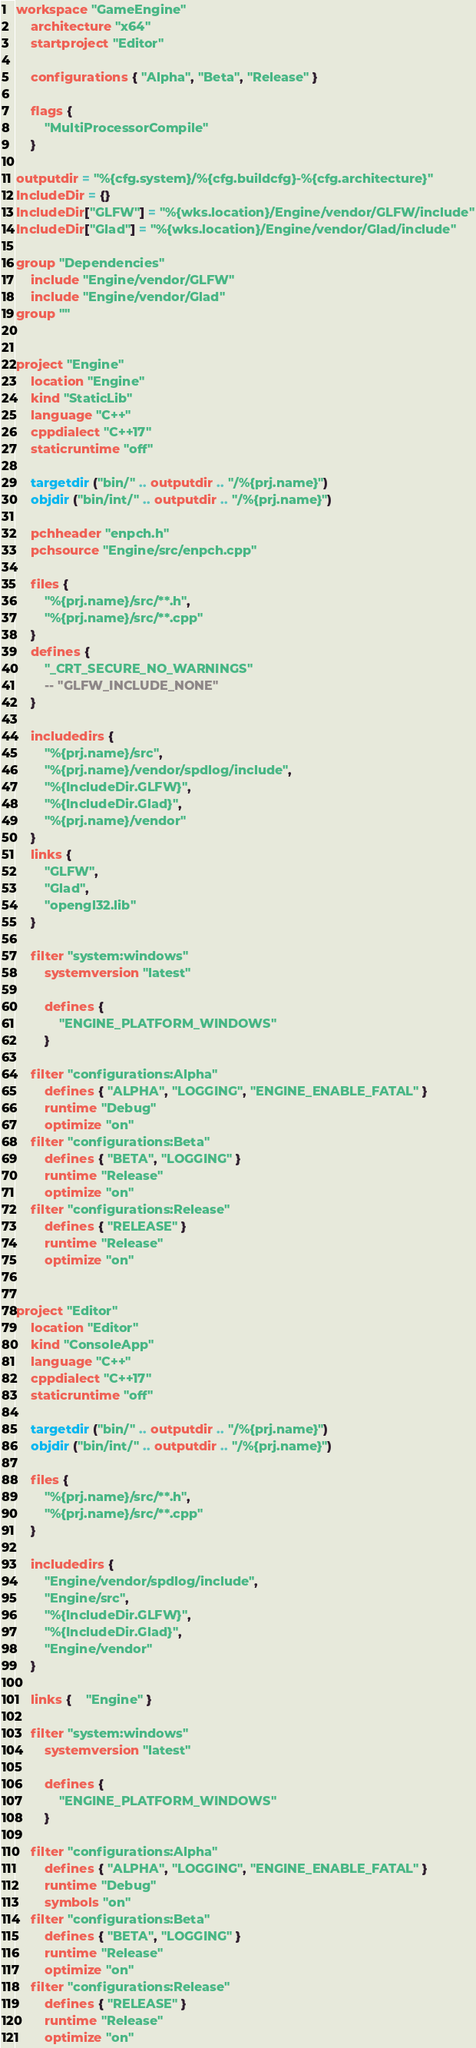<code> <loc_0><loc_0><loc_500><loc_500><_Lua_>workspace "GameEngine"
	architecture "x64"
	startproject "Editor"

	configurations { "Alpha", "Beta", "Release" }
	
	flags {
		"MultiProcessorCompile"
	}

outputdir = "%{cfg.system}/%{cfg.buildcfg}-%{cfg.architecture}"
IncludeDir = {}
IncludeDir["GLFW"] = "%{wks.location}/Engine/vendor/GLFW/include"
IncludeDir["Glad"] = "%{wks.location}/Engine/vendor/Glad/include"

group "Dependencies"
	include "Engine/vendor/GLFW"
	include "Engine/vendor/Glad"
group ""


project "Engine"
	location "Engine"
	kind "StaticLib"
	language "C++"
	cppdialect "C++17"
	staticruntime "off"
	
	targetdir ("bin/" .. outputdir .. "/%{prj.name}")
	objdir ("bin/int/" .. outputdir .. "/%{prj.name}")

	pchheader "enpch.h"
	pchsource "Engine/src/enpch.cpp"

	files {
		"%{prj.name}/src/**.h",
		"%{prj.name}/src/**.cpp"
	}
	defines {
		"_CRT_SECURE_NO_WARNINGS"
		-- "GLFW_INCLUDE_NONE"
	}

	includedirs {
		"%{prj.name}/src",
		"%{prj.name}/vendor/spdlog/include",
		"%{IncludeDir.GLFW}",
		"%{IncludeDir.Glad}",
		"%{prj.name}/vendor"
	}
	links {
		"GLFW",
		"Glad",
		"opengl32.lib"
	}

	filter "system:windows"
		systemversion "latest"

		defines {
			"ENGINE_PLATFORM_WINDOWS"
		}
		
	filter "configurations:Alpha"
		defines { "ALPHA", "LOGGING", "ENGINE_ENABLE_FATAL" }
		runtime "Debug"
		optimize "on"
	filter "configurations:Beta"
		defines { "BETA", "LOGGING" }
		runtime "Release"
		optimize "on"
	filter "configurations:Release"
		defines { "RELEASE" }
		runtime "Release"
		optimize "on"


project "Editor"
	location "Editor"
	kind "ConsoleApp"
	language "C++"
	cppdialect "C++17"
	staticruntime "off"
	
	targetdir ("bin/" .. outputdir .. "/%{prj.name}")
	objdir ("bin/int/" .. outputdir .. "/%{prj.name}")

	files {
		"%{prj.name}/src/**.h",
		"%{prj.name}/src/**.cpp"
	}

	includedirs {
		"Engine/vendor/spdlog/include",
		"Engine/src",
		"%{IncludeDir.GLFW}",
		"%{IncludeDir.Glad}",
		"Engine/vendor"
	}

	links {	"Engine" }

	filter "system:windows"
		systemversion "latest"

		defines {
			"ENGINE_PLATFORM_WINDOWS"
		}
		
	filter "configurations:Alpha"
		defines { "ALPHA", "LOGGING", "ENGINE_ENABLE_FATAL" }
		runtime "Debug"
		symbols "on"
	filter "configurations:Beta"
		defines { "BETA", "LOGGING" }
		runtime "Release"
		optimize "on"
	filter "configurations:Release"
		defines { "RELEASE" }
		runtime "Release"
		optimize "on"




</code> 